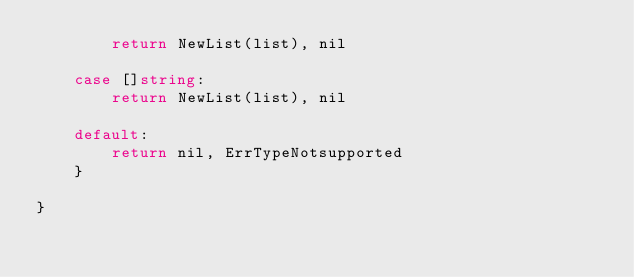<code> <loc_0><loc_0><loc_500><loc_500><_Go_>		return NewList(list), nil

	case []string:
		return NewList(list), nil

	default:
		return nil, ErrTypeNotsupported
	}

}
</code> 